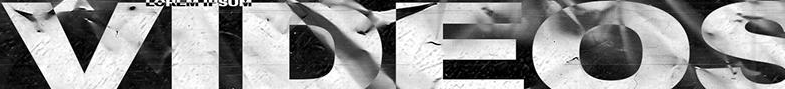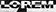Transcribe the words shown in these images in order, separated by a semicolon. VIDEOS; LOPEM 